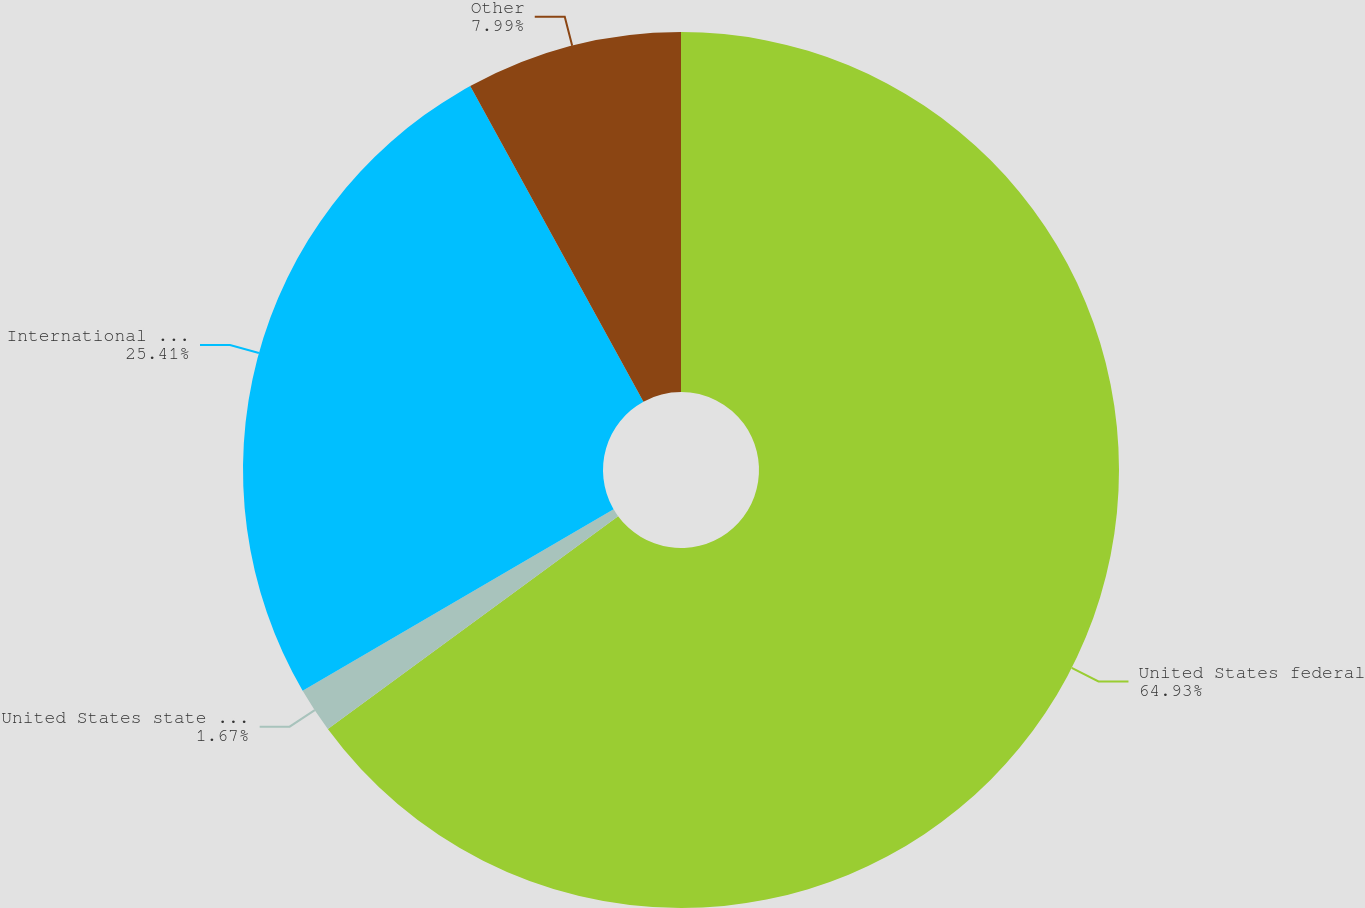Convert chart to OTSL. <chart><loc_0><loc_0><loc_500><loc_500><pie_chart><fcel>United States federal<fcel>United States state and local<fcel>International operations<fcel>Other<nl><fcel>64.92%<fcel>1.67%<fcel>25.41%<fcel>7.99%<nl></chart> 